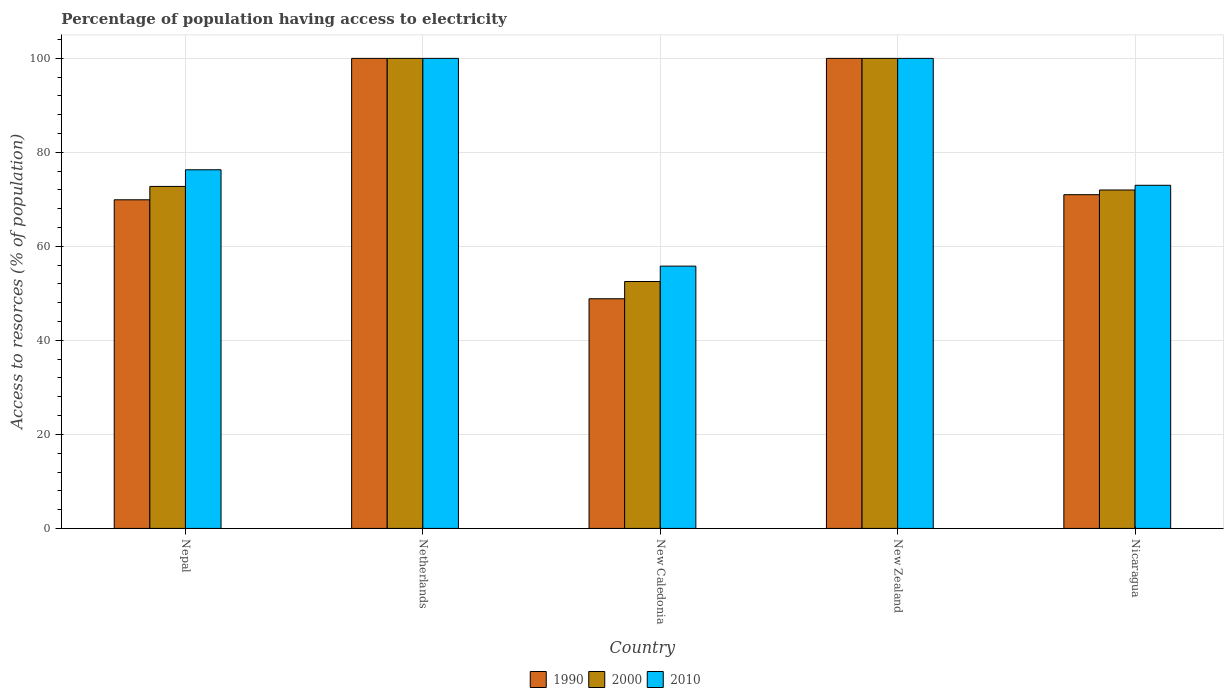How many groups of bars are there?
Keep it short and to the point. 5. How many bars are there on the 2nd tick from the right?
Provide a succinct answer. 3. What is the label of the 3rd group of bars from the left?
Offer a terse response. New Caledonia. What is the percentage of population having access to electricity in 2000 in New Caledonia?
Your response must be concise. 52.53. Across all countries, what is the maximum percentage of population having access to electricity in 2010?
Keep it short and to the point. 100. Across all countries, what is the minimum percentage of population having access to electricity in 2000?
Provide a succinct answer. 52.53. In which country was the percentage of population having access to electricity in 1990 minimum?
Ensure brevity in your answer.  New Caledonia. What is the total percentage of population having access to electricity in 2000 in the graph?
Your answer should be compact. 397.29. What is the difference between the percentage of population having access to electricity in 2000 in New Caledonia and that in Nicaragua?
Your answer should be compact. -19.47. What is the difference between the percentage of population having access to electricity in 2010 in New Caledonia and the percentage of population having access to electricity in 1990 in New Zealand?
Your answer should be compact. -44.2. What is the average percentage of population having access to electricity in 1990 per country?
Make the answer very short. 77.95. What is the difference between the percentage of population having access to electricity of/in 2010 and percentage of population having access to electricity of/in 1990 in New Caledonia?
Provide a short and direct response. 6.94. What is the ratio of the percentage of population having access to electricity in 2010 in Netherlands to that in New Zealand?
Your response must be concise. 1. Is the difference between the percentage of population having access to electricity in 2010 in Netherlands and New Caledonia greater than the difference between the percentage of population having access to electricity in 1990 in Netherlands and New Caledonia?
Your answer should be very brief. No. What is the difference between the highest and the second highest percentage of population having access to electricity in 1990?
Provide a short and direct response. 29. What is the difference between the highest and the lowest percentage of population having access to electricity in 2010?
Make the answer very short. 44.2. Is the sum of the percentage of population having access to electricity in 2010 in New Zealand and Nicaragua greater than the maximum percentage of population having access to electricity in 2000 across all countries?
Your answer should be very brief. Yes. What does the 3rd bar from the right in Netherlands represents?
Your answer should be very brief. 1990. How many bars are there?
Ensure brevity in your answer.  15. Are all the bars in the graph horizontal?
Provide a short and direct response. No. Does the graph contain any zero values?
Offer a very short reply. No. Where does the legend appear in the graph?
Make the answer very short. Bottom center. How many legend labels are there?
Your answer should be compact. 3. What is the title of the graph?
Provide a short and direct response. Percentage of population having access to electricity. What is the label or title of the Y-axis?
Your response must be concise. Access to resorces (% of population). What is the Access to resorces (% of population) of 1990 in Nepal?
Your answer should be very brief. 69.92. What is the Access to resorces (% of population) of 2000 in Nepal?
Make the answer very short. 72.76. What is the Access to resorces (% of population) in 2010 in Nepal?
Your answer should be very brief. 76.3. What is the Access to resorces (% of population) of 1990 in Netherlands?
Your answer should be compact. 100. What is the Access to resorces (% of population) in 2000 in Netherlands?
Provide a succinct answer. 100. What is the Access to resorces (% of population) of 1990 in New Caledonia?
Your answer should be very brief. 48.86. What is the Access to resorces (% of population) in 2000 in New Caledonia?
Keep it short and to the point. 52.53. What is the Access to resorces (% of population) of 2010 in New Caledonia?
Provide a succinct answer. 55.8. What is the Access to resorces (% of population) in 2000 in New Zealand?
Ensure brevity in your answer.  100. What is the Access to resorces (% of population) in 2010 in New Zealand?
Your answer should be compact. 100. What is the Access to resorces (% of population) in 1990 in Nicaragua?
Offer a very short reply. 71. What is the Access to resorces (% of population) of 2000 in Nicaragua?
Give a very brief answer. 72. Across all countries, what is the maximum Access to resorces (% of population) in 1990?
Make the answer very short. 100. Across all countries, what is the maximum Access to resorces (% of population) of 2000?
Give a very brief answer. 100. Across all countries, what is the maximum Access to resorces (% of population) of 2010?
Ensure brevity in your answer.  100. Across all countries, what is the minimum Access to resorces (% of population) in 1990?
Give a very brief answer. 48.86. Across all countries, what is the minimum Access to resorces (% of population) in 2000?
Ensure brevity in your answer.  52.53. Across all countries, what is the minimum Access to resorces (% of population) in 2010?
Your answer should be very brief. 55.8. What is the total Access to resorces (% of population) of 1990 in the graph?
Ensure brevity in your answer.  389.77. What is the total Access to resorces (% of population) of 2000 in the graph?
Provide a succinct answer. 397.29. What is the total Access to resorces (% of population) of 2010 in the graph?
Give a very brief answer. 405.1. What is the difference between the Access to resorces (% of population) of 1990 in Nepal and that in Netherlands?
Offer a very short reply. -30.08. What is the difference between the Access to resorces (% of population) in 2000 in Nepal and that in Netherlands?
Offer a very short reply. -27.24. What is the difference between the Access to resorces (% of population) in 2010 in Nepal and that in Netherlands?
Ensure brevity in your answer.  -23.7. What is the difference between the Access to resorces (% of population) in 1990 in Nepal and that in New Caledonia?
Offer a terse response. 21.06. What is the difference between the Access to resorces (% of population) of 2000 in Nepal and that in New Caledonia?
Provide a short and direct response. 20.23. What is the difference between the Access to resorces (% of population) of 2010 in Nepal and that in New Caledonia?
Offer a very short reply. 20.5. What is the difference between the Access to resorces (% of population) in 1990 in Nepal and that in New Zealand?
Your answer should be compact. -30.08. What is the difference between the Access to resorces (% of population) in 2000 in Nepal and that in New Zealand?
Provide a succinct answer. -27.24. What is the difference between the Access to resorces (% of population) in 2010 in Nepal and that in New Zealand?
Provide a succinct answer. -23.7. What is the difference between the Access to resorces (% of population) of 1990 in Nepal and that in Nicaragua?
Make the answer very short. -1.08. What is the difference between the Access to resorces (% of population) of 2000 in Nepal and that in Nicaragua?
Offer a terse response. 0.76. What is the difference between the Access to resorces (% of population) in 1990 in Netherlands and that in New Caledonia?
Provide a succinct answer. 51.14. What is the difference between the Access to resorces (% of population) of 2000 in Netherlands and that in New Caledonia?
Your answer should be compact. 47.47. What is the difference between the Access to resorces (% of population) of 2010 in Netherlands and that in New Caledonia?
Give a very brief answer. 44.2. What is the difference between the Access to resorces (% of population) of 2000 in Netherlands and that in Nicaragua?
Provide a short and direct response. 28. What is the difference between the Access to resorces (% of population) in 1990 in New Caledonia and that in New Zealand?
Give a very brief answer. -51.14. What is the difference between the Access to resorces (% of population) of 2000 in New Caledonia and that in New Zealand?
Ensure brevity in your answer.  -47.47. What is the difference between the Access to resorces (% of population) of 2010 in New Caledonia and that in New Zealand?
Your response must be concise. -44.2. What is the difference between the Access to resorces (% of population) in 1990 in New Caledonia and that in Nicaragua?
Provide a succinct answer. -22.14. What is the difference between the Access to resorces (% of population) in 2000 in New Caledonia and that in Nicaragua?
Offer a very short reply. -19.47. What is the difference between the Access to resorces (% of population) of 2010 in New Caledonia and that in Nicaragua?
Make the answer very short. -17.2. What is the difference between the Access to resorces (% of population) of 2000 in New Zealand and that in Nicaragua?
Provide a succinct answer. 28. What is the difference between the Access to resorces (% of population) of 2010 in New Zealand and that in Nicaragua?
Your answer should be very brief. 27. What is the difference between the Access to resorces (% of population) of 1990 in Nepal and the Access to resorces (% of population) of 2000 in Netherlands?
Offer a very short reply. -30.08. What is the difference between the Access to resorces (% of population) of 1990 in Nepal and the Access to resorces (% of population) of 2010 in Netherlands?
Give a very brief answer. -30.08. What is the difference between the Access to resorces (% of population) of 2000 in Nepal and the Access to resorces (% of population) of 2010 in Netherlands?
Make the answer very short. -27.24. What is the difference between the Access to resorces (% of population) of 1990 in Nepal and the Access to resorces (% of population) of 2000 in New Caledonia?
Keep it short and to the point. 17.39. What is the difference between the Access to resorces (% of population) of 1990 in Nepal and the Access to resorces (% of population) of 2010 in New Caledonia?
Keep it short and to the point. 14.12. What is the difference between the Access to resorces (% of population) in 2000 in Nepal and the Access to resorces (% of population) in 2010 in New Caledonia?
Ensure brevity in your answer.  16.96. What is the difference between the Access to resorces (% of population) of 1990 in Nepal and the Access to resorces (% of population) of 2000 in New Zealand?
Offer a terse response. -30.08. What is the difference between the Access to resorces (% of population) of 1990 in Nepal and the Access to resorces (% of population) of 2010 in New Zealand?
Your answer should be compact. -30.08. What is the difference between the Access to resorces (% of population) in 2000 in Nepal and the Access to resorces (% of population) in 2010 in New Zealand?
Offer a terse response. -27.24. What is the difference between the Access to resorces (% of population) in 1990 in Nepal and the Access to resorces (% of population) in 2000 in Nicaragua?
Your response must be concise. -2.08. What is the difference between the Access to resorces (% of population) in 1990 in Nepal and the Access to resorces (% of population) in 2010 in Nicaragua?
Offer a terse response. -3.08. What is the difference between the Access to resorces (% of population) of 2000 in Nepal and the Access to resorces (% of population) of 2010 in Nicaragua?
Ensure brevity in your answer.  -0.24. What is the difference between the Access to resorces (% of population) of 1990 in Netherlands and the Access to resorces (% of population) of 2000 in New Caledonia?
Your answer should be compact. 47.47. What is the difference between the Access to resorces (% of population) in 1990 in Netherlands and the Access to resorces (% of population) in 2010 in New Caledonia?
Offer a terse response. 44.2. What is the difference between the Access to resorces (% of population) in 2000 in Netherlands and the Access to resorces (% of population) in 2010 in New Caledonia?
Your answer should be compact. 44.2. What is the difference between the Access to resorces (% of population) in 1990 in Netherlands and the Access to resorces (% of population) in 2000 in New Zealand?
Keep it short and to the point. 0. What is the difference between the Access to resorces (% of population) of 1990 in Netherlands and the Access to resorces (% of population) of 2010 in New Zealand?
Keep it short and to the point. 0. What is the difference between the Access to resorces (% of population) in 2000 in Netherlands and the Access to resorces (% of population) in 2010 in New Zealand?
Your answer should be very brief. 0. What is the difference between the Access to resorces (% of population) in 1990 in Netherlands and the Access to resorces (% of population) in 2000 in Nicaragua?
Your response must be concise. 28. What is the difference between the Access to resorces (% of population) of 1990 in Netherlands and the Access to resorces (% of population) of 2010 in Nicaragua?
Your response must be concise. 27. What is the difference between the Access to resorces (% of population) of 2000 in Netherlands and the Access to resorces (% of population) of 2010 in Nicaragua?
Make the answer very short. 27. What is the difference between the Access to resorces (% of population) in 1990 in New Caledonia and the Access to resorces (% of population) in 2000 in New Zealand?
Keep it short and to the point. -51.14. What is the difference between the Access to resorces (% of population) of 1990 in New Caledonia and the Access to resorces (% of population) of 2010 in New Zealand?
Your answer should be very brief. -51.14. What is the difference between the Access to resorces (% of population) of 2000 in New Caledonia and the Access to resorces (% of population) of 2010 in New Zealand?
Your answer should be compact. -47.47. What is the difference between the Access to resorces (% of population) of 1990 in New Caledonia and the Access to resorces (% of population) of 2000 in Nicaragua?
Your response must be concise. -23.14. What is the difference between the Access to resorces (% of population) of 1990 in New Caledonia and the Access to resorces (% of population) of 2010 in Nicaragua?
Your answer should be very brief. -24.14. What is the difference between the Access to resorces (% of population) in 2000 in New Caledonia and the Access to resorces (% of population) in 2010 in Nicaragua?
Ensure brevity in your answer.  -20.47. What is the difference between the Access to resorces (% of population) of 1990 in New Zealand and the Access to resorces (% of population) of 2000 in Nicaragua?
Your answer should be very brief. 28. What is the average Access to resorces (% of population) in 1990 per country?
Provide a short and direct response. 77.95. What is the average Access to resorces (% of population) in 2000 per country?
Provide a succinct answer. 79.46. What is the average Access to resorces (% of population) in 2010 per country?
Offer a terse response. 81.02. What is the difference between the Access to resorces (% of population) of 1990 and Access to resorces (% of population) of 2000 in Nepal?
Keep it short and to the point. -2.84. What is the difference between the Access to resorces (% of population) in 1990 and Access to resorces (% of population) in 2010 in Nepal?
Make the answer very short. -6.38. What is the difference between the Access to resorces (% of population) in 2000 and Access to resorces (% of population) in 2010 in Nepal?
Your answer should be very brief. -3.54. What is the difference between the Access to resorces (% of population) of 1990 and Access to resorces (% of population) of 2000 in Netherlands?
Give a very brief answer. 0. What is the difference between the Access to resorces (% of population) of 2000 and Access to resorces (% of population) of 2010 in Netherlands?
Your answer should be very brief. 0. What is the difference between the Access to resorces (% of population) of 1990 and Access to resorces (% of population) of 2000 in New Caledonia?
Offer a terse response. -3.67. What is the difference between the Access to resorces (% of population) of 1990 and Access to resorces (% of population) of 2010 in New Caledonia?
Provide a succinct answer. -6.94. What is the difference between the Access to resorces (% of population) in 2000 and Access to resorces (% of population) in 2010 in New Caledonia?
Offer a terse response. -3.27. What is the difference between the Access to resorces (% of population) in 1990 and Access to resorces (% of population) in 2000 in New Zealand?
Your answer should be very brief. 0. What is the difference between the Access to resorces (% of population) of 1990 and Access to resorces (% of population) of 2010 in New Zealand?
Keep it short and to the point. 0. What is the difference between the Access to resorces (% of population) in 2000 and Access to resorces (% of population) in 2010 in New Zealand?
Make the answer very short. 0. What is the difference between the Access to resorces (% of population) of 1990 and Access to resorces (% of population) of 2000 in Nicaragua?
Ensure brevity in your answer.  -1. What is the difference between the Access to resorces (% of population) of 1990 and Access to resorces (% of population) of 2010 in Nicaragua?
Offer a terse response. -2. What is the difference between the Access to resorces (% of population) of 2000 and Access to resorces (% of population) of 2010 in Nicaragua?
Your answer should be very brief. -1. What is the ratio of the Access to resorces (% of population) in 1990 in Nepal to that in Netherlands?
Offer a terse response. 0.7. What is the ratio of the Access to resorces (% of population) of 2000 in Nepal to that in Netherlands?
Give a very brief answer. 0.73. What is the ratio of the Access to resorces (% of population) of 2010 in Nepal to that in Netherlands?
Provide a succinct answer. 0.76. What is the ratio of the Access to resorces (% of population) of 1990 in Nepal to that in New Caledonia?
Keep it short and to the point. 1.43. What is the ratio of the Access to resorces (% of population) in 2000 in Nepal to that in New Caledonia?
Make the answer very short. 1.39. What is the ratio of the Access to resorces (% of population) in 2010 in Nepal to that in New Caledonia?
Ensure brevity in your answer.  1.37. What is the ratio of the Access to resorces (% of population) in 1990 in Nepal to that in New Zealand?
Your response must be concise. 0.7. What is the ratio of the Access to resorces (% of population) in 2000 in Nepal to that in New Zealand?
Keep it short and to the point. 0.73. What is the ratio of the Access to resorces (% of population) of 2010 in Nepal to that in New Zealand?
Give a very brief answer. 0.76. What is the ratio of the Access to resorces (% of population) in 1990 in Nepal to that in Nicaragua?
Your answer should be compact. 0.98. What is the ratio of the Access to resorces (% of population) of 2000 in Nepal to that in Nicaragua?
Your answer should be very brief. 1.01. What is the ratio of the Access to resorces (% of population) of 2010 in Nepal to that in Nicaragua?
Keep it short and to the point. 1.05. What is the ratio of the Access to resorces (% of population) in 1990 in Netherlands to that in New Caledonia?
Your response must be concise. 2.05. What is the ratio of the Access to resorces (% of population) in 2000 in Netherlands to that in New Caledonia?
Your response must be concise. 1.9. What is the ratio of the Access to resorces (% of population) of 2010 in Netherlands to that in New Caledonia?
Provide a succinct answer. 1.79. What is the ratio of the Access to resorces (% of population) of 1990 in Netherlands to that in New Zealand?
Your response must be concise. 1. What is the ratio of the Access to resorces (% of population) in 2000 in Netherlands to that in New Zealand?
Offer a terse response. 1. What is the ratio of the Access to resorces (% of population) of 1990 in Netherlands to that in Nicaragua?
Offer a very short reply. 1.41. What is the ratio of the Access to resorces (% of population) in 2000 in Netherlands to that in Nicaragua?
Give a very brief answer. 1.39. What is the ratio of the Access to resorces (% of population) in 2010 in Netherlands to that in Nicaragua?
Your answer should be very brief. 1.37. What is the ratio of the Access to resorces (% of population) in 1990 in New Caledonia to that in New Zealand?
Offer a terse response. 0.49. What is the ratio of the Access to resorces (% of population) in 2000 in New Caledonia to that in New Zealand?
Your answer should be compact. 0.53. What is the ratio of the Access to resorces (% of population) of 2010 in New Caledonia to that in New Zealand?
Your answer should be very brief. 0.56. What is the ratio of the Access to resorces (% of population) in 1990 in New Caledonia to that in Nicaragua?
Provide a short and direct response. 0.69. What is the ratio of the Access to resorces (% of population) in 2000 in New Caledonia to that in Nicaragua?
Ensure brevity in your answer.  0.73. What is the ratio of the Access to resorces (% of population) of 2010 in New Caledonia to that in Nicaragua?
Ensure brevity in your answer.  0.76. What is the ratio of the Access to resorces (% of population) of 1990 in New Zealand to that in Nicaragua?
Offer a very short reply. 1.41. What is the ratio of the Access to resorces (% of population) in 2000 in New Zealand to that in Nicaragua?
Keep it short and to the point. 1.39. What is the ratio of the Access to resorces (% of population) of 2010 in New Zealand to that in Nicaragua?
Your response must be concise. 1.37. What is the difference between the highest and the lowest Access to resorces (% of population) in 1990?
Offer a very short reply. 51.14. What is the difference between the highest and the lowest Access to resorces (% of population) in 2000?
Give a very brief answer. 47.47. What is the difference between the highest and the lowest Access to resorces (% of population) of 2010?
Keep it short and to the point. 44.2. 